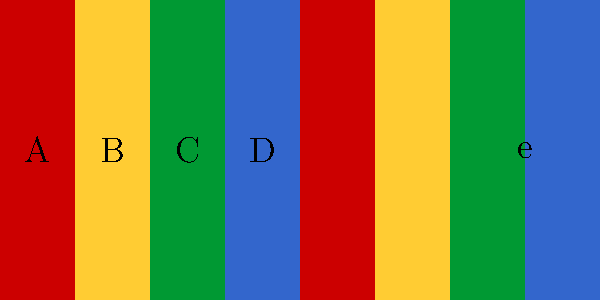Consider the pattern on this kimono obi sash, where each colored rectangle represents an element of a cyclic group $C_4 = \{e, a, b, c\}$. If we define the group operation as moving one step to the right (with $e$ as the identity element), what element of the group does the transformation from the leftmost rectangle to the fifth rectangle represent? Let's approach this step-by-step:

1) First, we need to identify the elements of the group $C_4$ in the pattern:
   - Red (A) represents $a$
   - Yellow (B) represents $b$
   - Green (C) represents $c$
   - Blue (D) represents $e$ (the identity element)

2) The group operation is defined as moving one step to the right. This means:
   - $a * a = b$
   - $b * a = c$
   - $c * a = e$
   - $e * a = a$

3) To get from the leftmost rectangle to the fifth rectangle, we need to move 4 steps to the right.

4) In group theory notation, this is equivalent to applying the operation $a$ four times:
   $a * a * a * a = a^4$

5) Let's calculate this step by step:
   - $a * a = b$
   - $b * a = c$
   - $c * a = e$

6) Therefore, $a^4 = e$, which is the identity element.

7) This makes sense because in a cyclic group of order 4, applying the generator 4 times brings us back to the identity element.
Answer: $e$ (the identity element) 